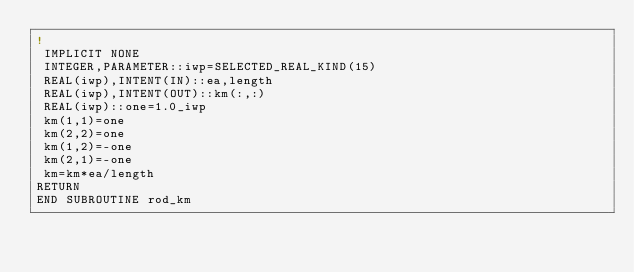<code> <loc_0><loc_0><loc_500><loc_500><_FORTRAN_>!
 IMPLICIT NONE
 INTEGER,PARAMETER::iwp=SELECTED_REAL_KIND(15)
 REAL(iwp),INTENT(IN)::ea,length
 REAL(iwp),INTENT(OUT)::km(:,:)
 REAL(iwp)::one=1.0_iwp
 km(1,1)=one
 km(2,2)=one
 km(1,2)=-one
 km(2,1)=-one
 km=km*ea/length
RETURN
END SUBROUTINE rod_km
</code> 